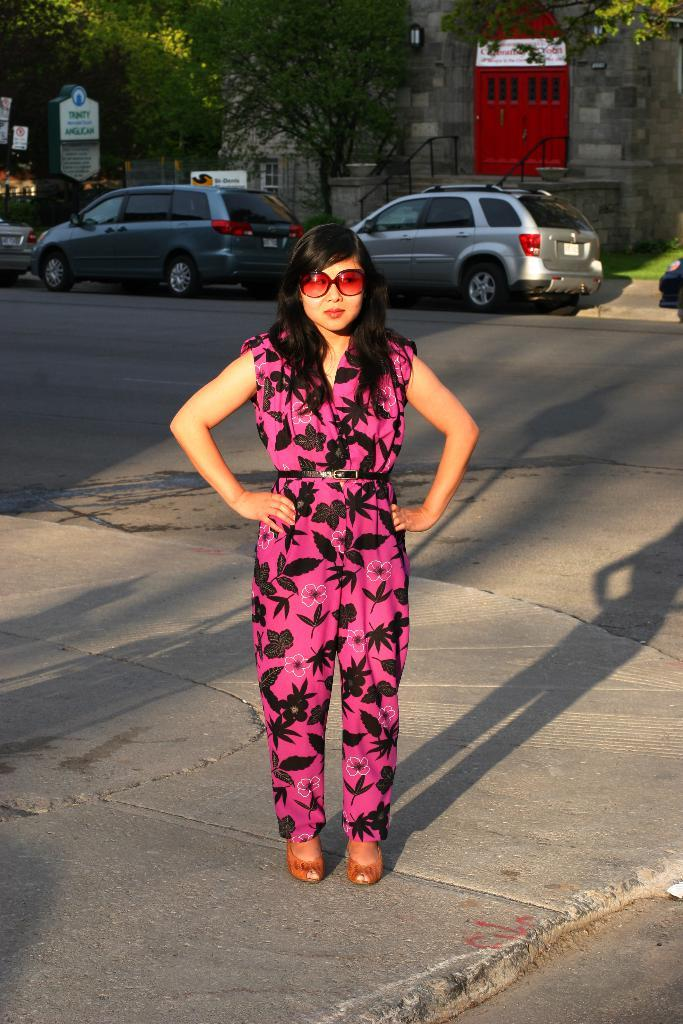What is the woman doing in the image? The woman is standing in the image. What is the woman wearing on her face? The woman is wearing goggles. What can be seen in the background of the image? There is a building, trees, a board, and cars in the background of the image. What type of grain is being harvested in the image? There is no grain or harvesting activity present in the image. What operation is the woman performing on the ground in the image? The woman is not performing any operation on the ground in the image; she is simply standing and wearing goggles. 